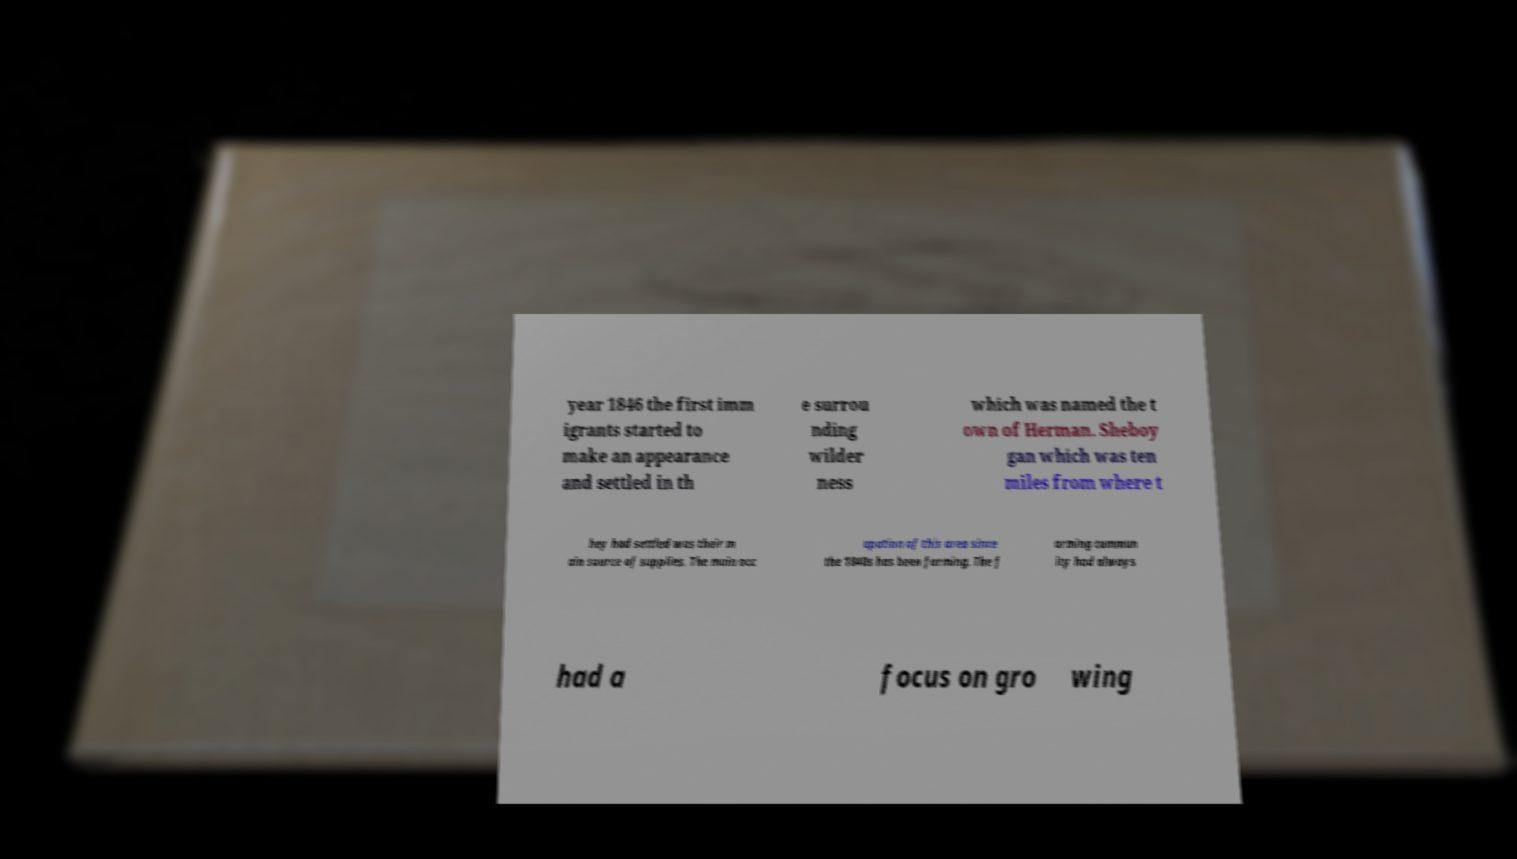I need the written content from this picture converted into text. Can you do that? year 1846 the first imm igrants started to make an appearance and settled in th e surrou nding wilder ness which was named the t own of Herman. Sheboy gan which was ten miles from where t hey had settled was their m ain source of supplies. The main occ upation of this area since the 1840s has been farming. The f arming commun ity had always had a focus on gro wing 